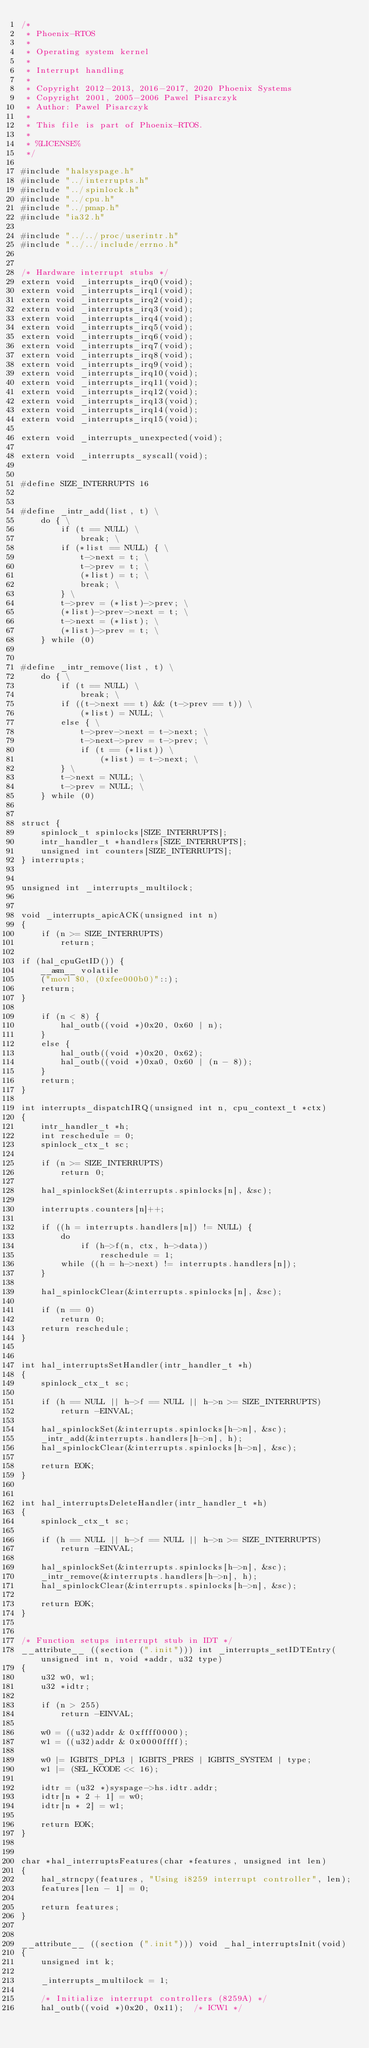<code> <loc_0><loc_0><loc_500><loc_500><_C_>/*
 * Phoenix-RTOS
 *
 * Operating system kernel
 *
 * Interrupt handling
 *
 * Copyright 2012-2013, 2016-2017, 2020 Phoenix Systems
 * Copyright 2001, 2005-2006 Pawel Pisarczyk
 * Author: Pawel Pisarczyk
 *
 * This file is part of Phoenix-RTOS.
 *
 * %LICENSE%
 */

#include "halsyspage.h"
#include "../interrupts.h"
#include "../spinlock.h"
#include "../cpu.h"
#include "../pmap.h"
#include "ia32.h"

#include "../../proc/userintr.h"
#include "../../include/errno.h"


/* Hardware interrupt stubs */
extern void _interrupts_irq0(void);
extern void _interrupts_irq1(void);
extern void _interrupts_irq2(void);
extern void _interrupts_irq3(void);
extern void _interrupts_irq4(void);
extern void _interrupts_irq5(void);
extern void _interrupts_irq6(void);
extern void _interrupts_irq7(void);
extern void _interrupts_irq8(void);
extern void _interrupts_irq9(void);
extern void _interrupts_irq10(void);
extern void _interrupts_irq11(void);
extern void _interrupts_irq12(void);
extern void _interrupts_irq13(void);
extern void _interrupts_irq14(void);
extern void _interrupts_irq15(void);

extern void _interrupts_unexpected(void);

extern void _interrupts_syscall(void);


#define SIZE_INTERRUPTS 16


#define _intr_add(list, t) \
	do { \
		if (t == NULL) \
			break; \
		if (*list == NULL) { \
			t->next = t; \
			t->prev = t; \
			(*list) = t; \
			break; \
		} \
		t->prev = (*list)->prev; \
		(*list)->prev->next = t; \
		t->next = (*list); \
		(*list)->prev = t; \
	} while (0)


#define _intr_remove(list, t) \
	do { \
		if (t == NULL) \
			break; \
		if ((t->next == t) && (t->prev == t)) \
			(*list) = NULL; \
		else { \
			t->prev->next = t->next; \
			t->next->prev = t->prev; \
			if (t == (*list)) \
				(*list) = t->next; \
		} \
		t->next = NULL; \
		t->prev = NULL; \
	} while (0)


struct {
	spinlock_t spinlocks[SIZE_INTERRUPTS];
	intr_handler_t *handlers[SIZE_INTERRUPTS];
	unsigned int counters[SIZE_INTERRUPTS];
} interrupts;


unsigned int _interrupts_multilock;


void _interrupts_apicACK(unsigned int n)
{
	if (n >= SIZE_INTERRUPTS)
		return;

if (hal_cpuGetID()) {
	__asm__ volatile
	("movl $0, (0xfee000b0)"::);
	return;
}

	if (n < 8) {
		hal_outb((void *)0x20, 0x60 | n);
	}
	else {
		hal_outb((void *)0x20, 0x62);
		hal_outb((void *)0xa0, 0x60 | (n - 8));
	}
	return;
}

int interrupts_dispatchIRQ(unsigned int n, cpu_context_t *ctx)
{
	intr_handler_t *h;
	int reschedule = 0;
	spinlock_ctx_t sc;

	if (n >= SIZE_INTERRUPTS)
		return 0;

	hal_spinlockSet(&interrupts.spinlocks[n], &sc);

	interrupts.counters[n]++;

	if ((h = interrupts.handlers[n]) != NULL) {
		do
			if (h->f(n, ctx, h->data))
				reschedule = 1;
		while ((h = h->next) != interrupts.handlers[n]);
	}

	hal_spinlockClear(&interrupts.spinlocks[n], &sc);

	if (n == 0)
		return 0;
	return reschedule;
}


int hal_interruptsSetHandler(intr_handler_t *h)
{
	spinlock_ctx_t sc;

	if (h == NULL || h->f == NULL || h->n >= SIZE_INTERRUPTS)
		return -EINVAL;

	hal_spinlockSet(&interrupts.spinlocks[h->n], &sc);
	_intr_add(&interrupts.handlers[h->n], h);
	hal_spinlockClear(&interrupts.spinlocks[h->n], &sc);

	return EOK;
}


int hal_interruptsDeleteHandler(intr_handler_t *h)
{
	spinlock_ctx_t sc;

	if (h == NULL || h->f == NULL || h->n >= SIZE_INTERRUPTS)
		return -EINVAL;

	hal_spinlockSet(&interrupts.spinlocks[h->n], &sc);
	_intr_remove(&interrupts.handlers[h->n], h);
	hal_spinlockClear(&interrupts.spinlocks[h->n], &sc);

	return EOK;
}


/* Function setups interrupt stub in IDT */
__attribute__ ((section (".init"))) int _interrupts_setIDTEntry(unsigned int n, void *addr, u32 type)
{
	u32 w0, w1;
	u32 *idtr;

	if (n > 255)
		return -EINVAL;

	w0 = ((u32)addr & 0xffff0000);
	w1 = ((u32)addr & 0x0000ffff);

	w0 |= IGBITS_DPL3 | IGBITS_PRES | IGBITS_SYSTEM | type;
	w1 |= (SEL_KCODE << 16);

	idtr = (u32 *)syspage->hs.idtr.addr;
	idtr[n * 2 + 1] = w0;
	idtr[n * 2] = w1;

	return EOK;
}


char *hal_interruptsFeatures(char *features, unsigned int len)
{
	hal_strncpy(features, "Using i8259 interrupt controller", len);
	features[len - 1] = 0;

	return features;
}


__attribute__ ((section (".init"))) void _hal_interruptsInit(void)
{
	unsigned int k;

	_interrupts_multilock = 1;

	/* Initialize interrupt controllers (8259A) */
	hal_outb((void *)0x20, 0x11);  /* ICW1 */</code> 